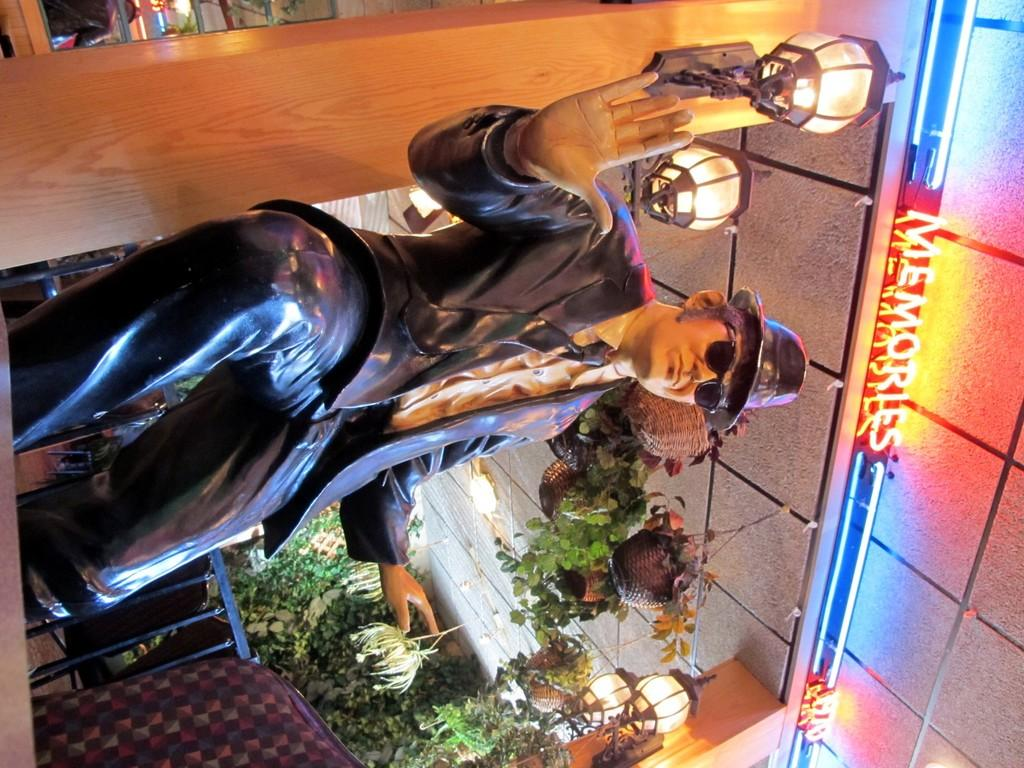What is the main subject in the image? There is a statue in the image. What else can be seen in the image besides the statue? There are plants, lights, hanging plants, and a board with text in the image. Can you describe the plants in the image? There are both regular plants and hanging plants in the image. What is written on the board in the image? Unfortunately, the specific text on the board cannot be determined from the provided facts. How does the statue sleep in the image? The statue does not sleep in the image, as statues are not living beings and cannot sleep. 